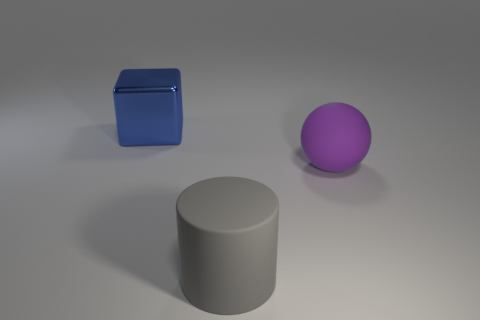Add 2 rubber balls. How many objects exist? 5 Subtract all cylinders. How many objects are left? 2 Subtract all small yellow rubber blocks. Subtract all big rubber things. How many objects are left? 1 Add 3 large purple balls. How many large purple balls are left? 4 Add 1 large blocks. How many large blocks exist? 2 Subtract 0 gray cubes. How many objects are left? 3 